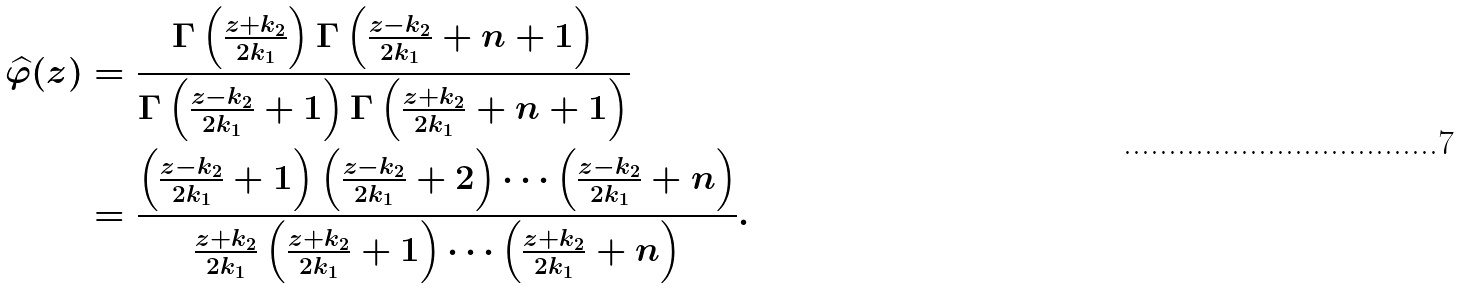Convert formula to latex. <formula><loc_0><loc_0><loc_500><loc_500>\widehat { \varphi } ( z ) & = \frac { \Gamma \left ( \frac { z + k _ { 2 } } { 2 k _ { 1 } } \right ) \Gamma \left ( \frac { z - k _ { 2 } } { 2 k _ { 1 } } + n + 1 \right ) } { \Gamma \left ( \frac { z - k _ { 2 } } { 2 k _ { 1 } } + 1 \right ) \Gamma \left ( \frac { z + k _ { 2 } } { 2 k _ { 1 } } + n + 1 \right ) } \\ & = \frac { \left ( \frac { z - k _ { 2 } } { 2 k _ { 1 } } + 1 \right ) \left ( \frac { z - k _ { 2 } } { 2 k _ { 1 } } + 2 \right ) \cdots \left ( \frac { z - k _ { 2 } } { 2 k _ { 1 } } + n \right ) } { \frac { z + k _ { 2 } } { 2 k _ { 1 } } \left ( \frac { z + k _ { 2 } } { 2 k _ { 1 } } + 1 \right ) \cdots \left ( \frac { z + k _ { 2 } } { 2 k _ { 1 } } + n \right ) } .</formula> 